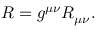<formula> <loc_0><loc_0><loc_500><loc_500>R = g ^ { \mu \nu } R _ { \mu \nu } .</formula> 